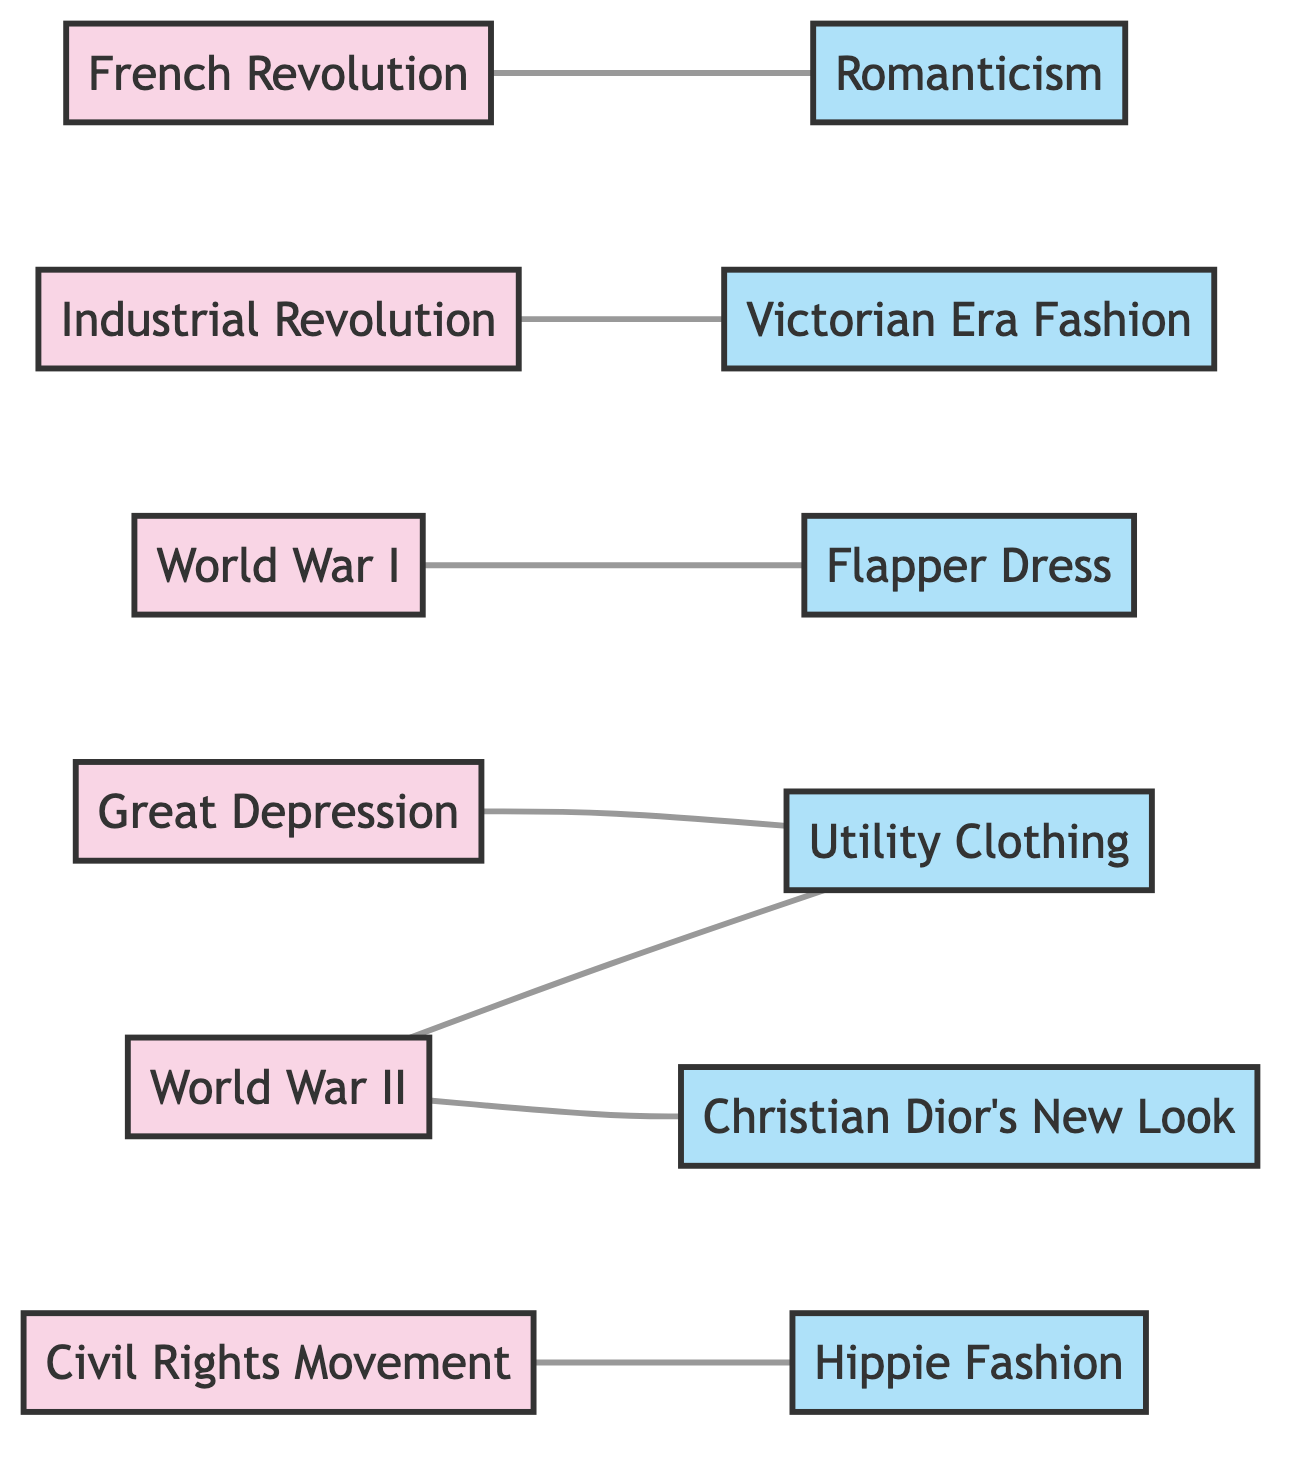What is the total number of nodes in the diagram? By counting the nodes listed in the diagram, we find there are 12 distinct entities related to socio-political events and fashion trends.
Answer: 12 Which socio-political event is connected to Romanticism? The edge connecting Romanticism indicates that the French Revolution directly influences this fashion trend.
Answer: French Revolution What fashion trend is associated with World War I? The diagram shows a direct connection between World War I and the Flapper Dress, indicating that this fashion trend emerged from this event.
Answer: Flapper Dress How many fashion trends are connected to the Great Depression? A review of the edges reveals that Utility Clothing is the only fashion trend linked to the Great Depression, making the answer one.
Answer: 1 Which socio-political event has connections to two fashion trends? Upon examining the edges, World War II is seen to connect with both Utility Clothing and Christian Dior's New Look, indicating its influence on two fashion trends.
Answer: World War II Which fashion trend is a result of the Civil Rights Movement? The diagram clearly shows a connection from the Civil Rights Movement to Hippie Fashion, indicating this influence.
Answer: Hippie Fashion What is the total number of edges representing the connections in the diagram? Counting the connections displayed (edges) in the diagram, we find a total of 6 distinct links between socio-political events and fashion trends.
Answer: 6 Are there any fashion trends that have no socio-political events linked to them? By reviewing the edges again, it shows that all fashion trends have at least one socio-political event connected to them, confirming there are none without connections.
Answer: No Which fashion trend is influenced by the Industrial Revolution? Based on the edge relationships, the Victorian Era Fashion is the identified trend stemming from the Industrial Revolution.
Answer: Victorian Era Fashion 